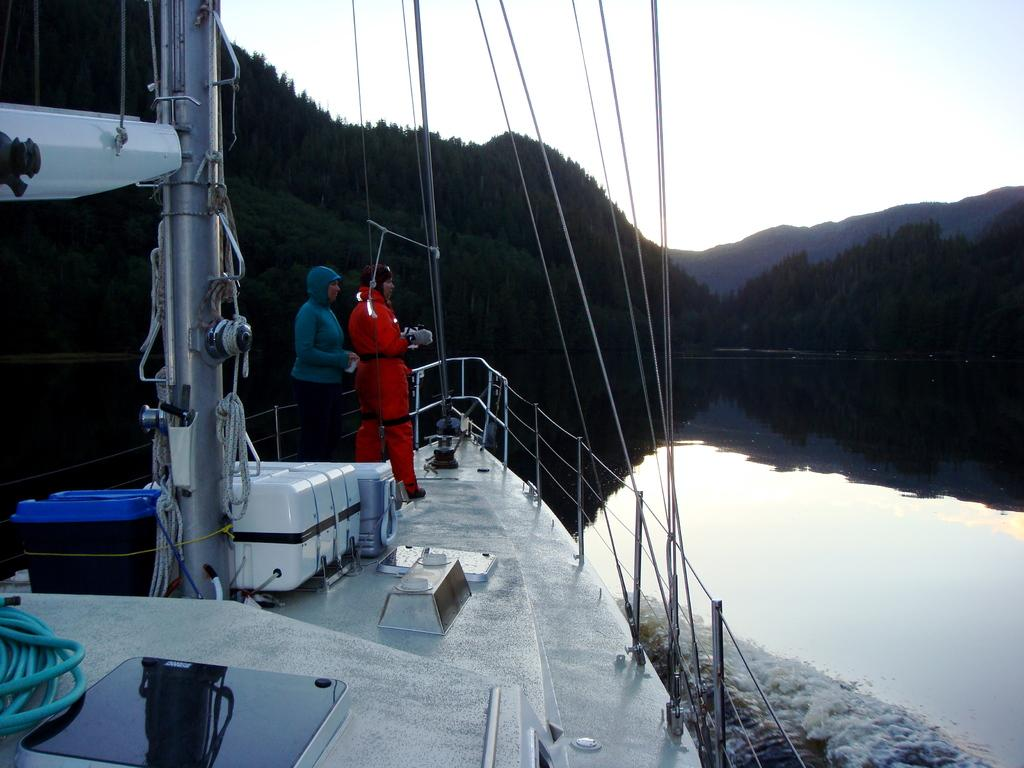How many people are in the ship in the image? There are 2 people standing in a ship in the image. What can be seen in the image besides the people and the ship? There are ropes, a fence, water, trees in the background, and the sky visible in the image. What is the purpose of the ropes in the image? The ropes in the image are likely used for securing or maneuvering the ship. What is the natural setting visible in the image? The natural setting includes trees and water. What type of wren can be seen perched on the fence in the image? There is no wren present in the image; it only features people, a ship, ropes, a fence, water, trees, and the sky. What is the texture of the water in the image? The texture of the water cannot be determined from the image alone, as it is a two-dimensional representation. 